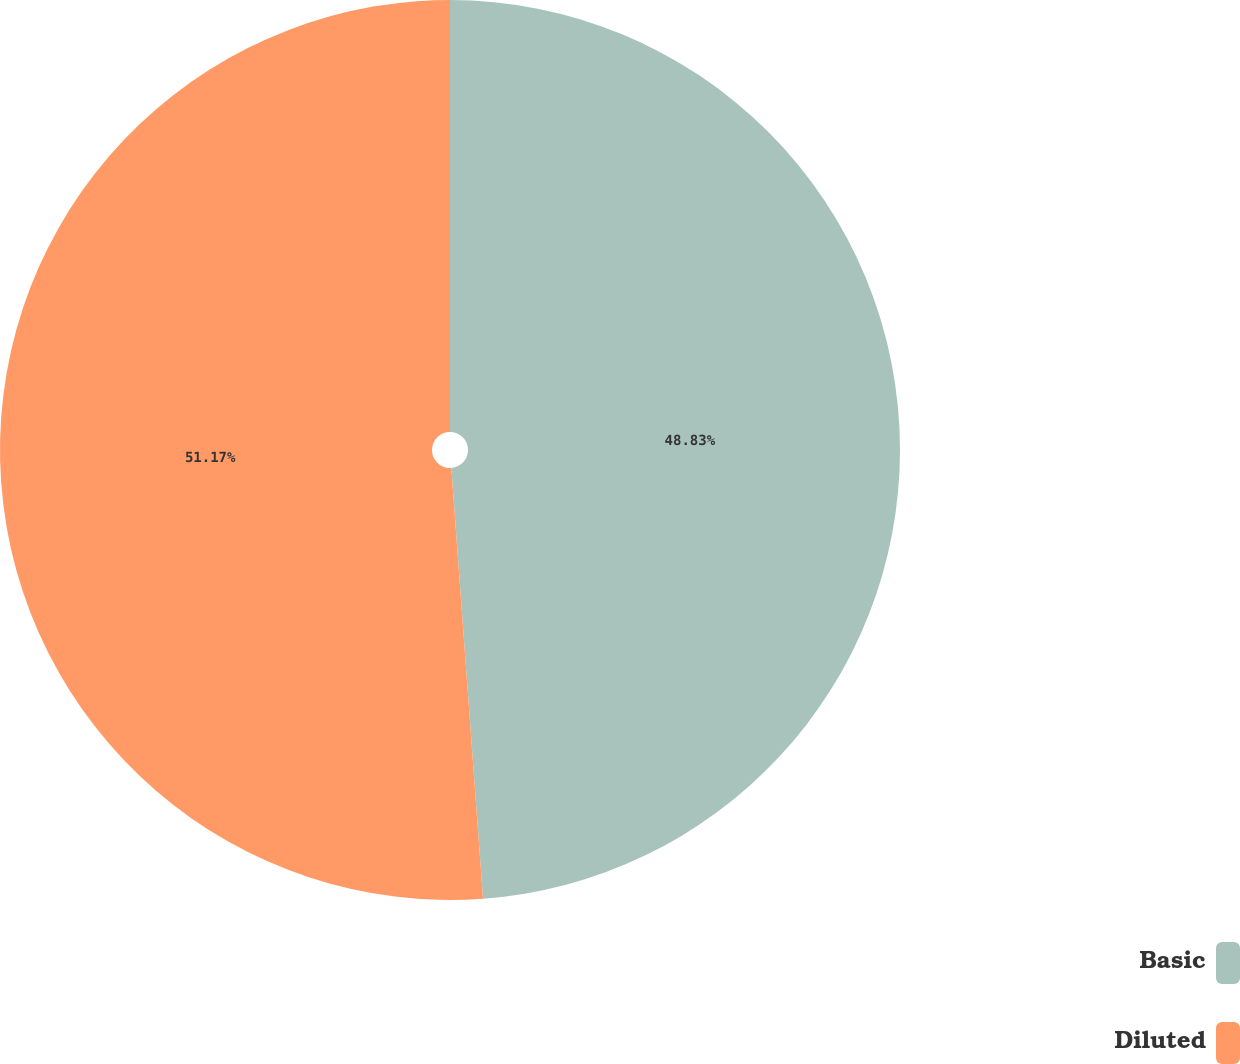Convert chart. <chart><loc_0><loc_0><loc_500><loc_500><pie_chart><fcel>Basic<fcel>Diluted<nl><fcel>48.83%<fcel>51.17%<nl></chart> 